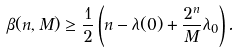<formula> <loc_0><loc_0><loc_500><loc_500>\beta ( n , M ) \geq \frac { 1 } { 2 } \left ( n - \lambda ( 0 ) + \frac { 2 ^ { n } } { M } \lambda _ { 0 } \right ) .</formula> 